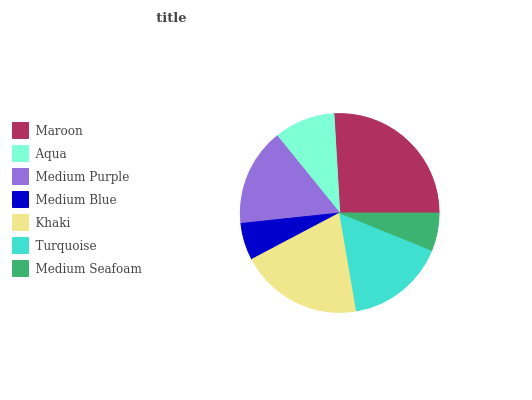Is Medium Blue the minimum?
Answer yes or no. Yes. Is Maroon the maximum?
Answer yes or no. Yes. Is Aqua the minimum?
Answer yes or no. No. Is Aqua the maximum?
Answer yes or no. No. Is Maroon greater than Aqua?
Answer yes or no. Yes. Is Aqua less than Maroon?
Answer yes or no. Yes. Is Aqua greater than Maroon?
Answer yes or no. No. Is Maroon less than Aqua?
Answer yes or no. No. Is Medium Purple the high median?
Answer yes or no. Yes. Is Medium Purple the low median?
Answer yes or no. Yes. Is Maroon the high median?
Answer yes or no. No. Is Medium Blue the low median?
Answer yes or no. No. 